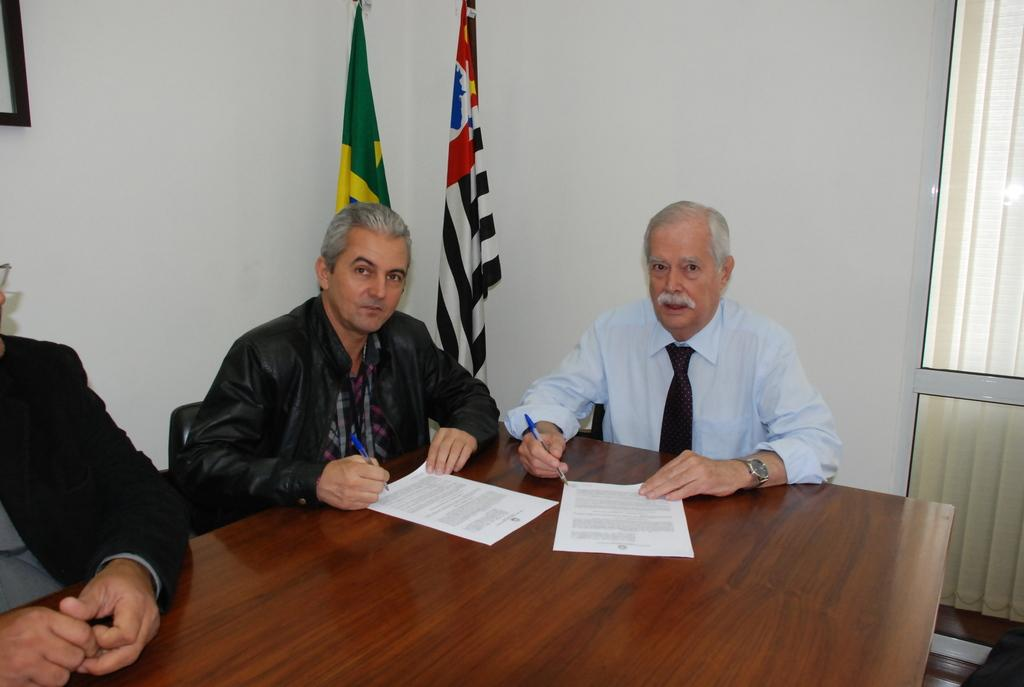How many people are in the image? There are three persons in front of the table. What is on the table? There are two papers on the table. What can be seen behind the table? There is a wall visible in the image. Is there any entrance or exit in the image? Yes, there is a door in the image. What decorative elements are present in the image? There are flags in the image. Can you tell me how many snails are crawling on the papers on the table? There are no snails present on the papers or in the image. What type of base is supporting the table in the image? The image does not provide information about the base of the table. 